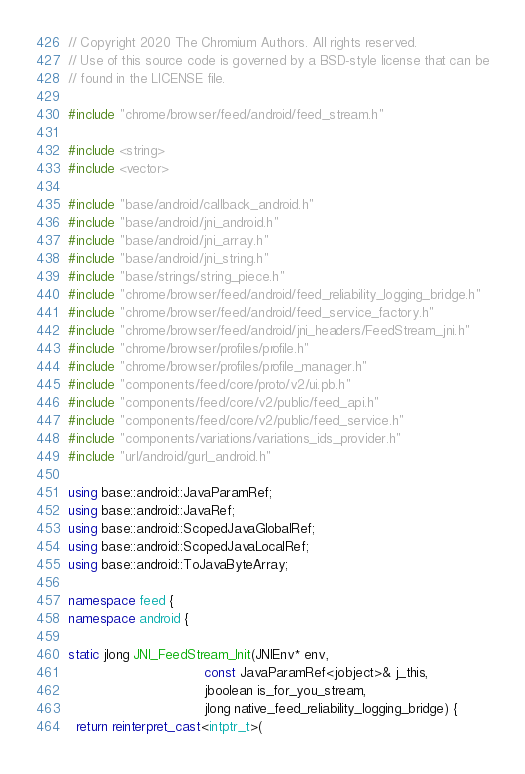Convert code to text. <code><loc_0><loc_0><loc_500><loc_500><_C++_>// Copyright 2020 The Chromium Authors. All rights reserved.
// Use of this source code is governed by a BSD-style license that can be
// found in the LICENSE file.

#include "chrome/browser/feed/android/feed_stream.h"

#include <string>
#include <vector>

#include "base/android/callback_android.h"
#include "base/android/jni_android.h"
#include "base/android/jni_array.h"
#include "base/android/jni_string.h"
#include "base/strings/string_piece.h"
#include "chrome/browser/feed/android/feed_reliability_logging_bridge.h"
#include "chrome/browser/feed/android/feed_service_factory.h"
#include "chrome/browser/feed/android/jni_headers/FeedStream_jni.h"
#include "chrome/browser/profiles/profile.h"
#include "chrome/browser/profiles/profile_manager.h"
#include "components/feed/core/proto/v2/ui.pb.h"
#include "components/feed/core/v2/public/feed_api.h"
#include "components/feed/core/v2/public/feed_service.h"
#include "components/variations/variations_ids_provider.h"
#include "url/android/gurl_android.h"

using base::android::JavaParamRef;
using base::android::JavaRef;
using base::android::ScopedJavaGlobalRef;
using base::android::ScopedJavaLocalRef;
using base::android::ToJavaByteArray;

namespace feed {
namespace android {

static jlong JNI_FeedStream_Init(JNIEnv* env,
                                 const JavaParamRef<jobject>& j_this,
                                 jboolean is_for_you_stream,
                                 jlong native_feed_reliability_logging_bridge) {
  return reinterpret_cast<intptr_t>(</code> 